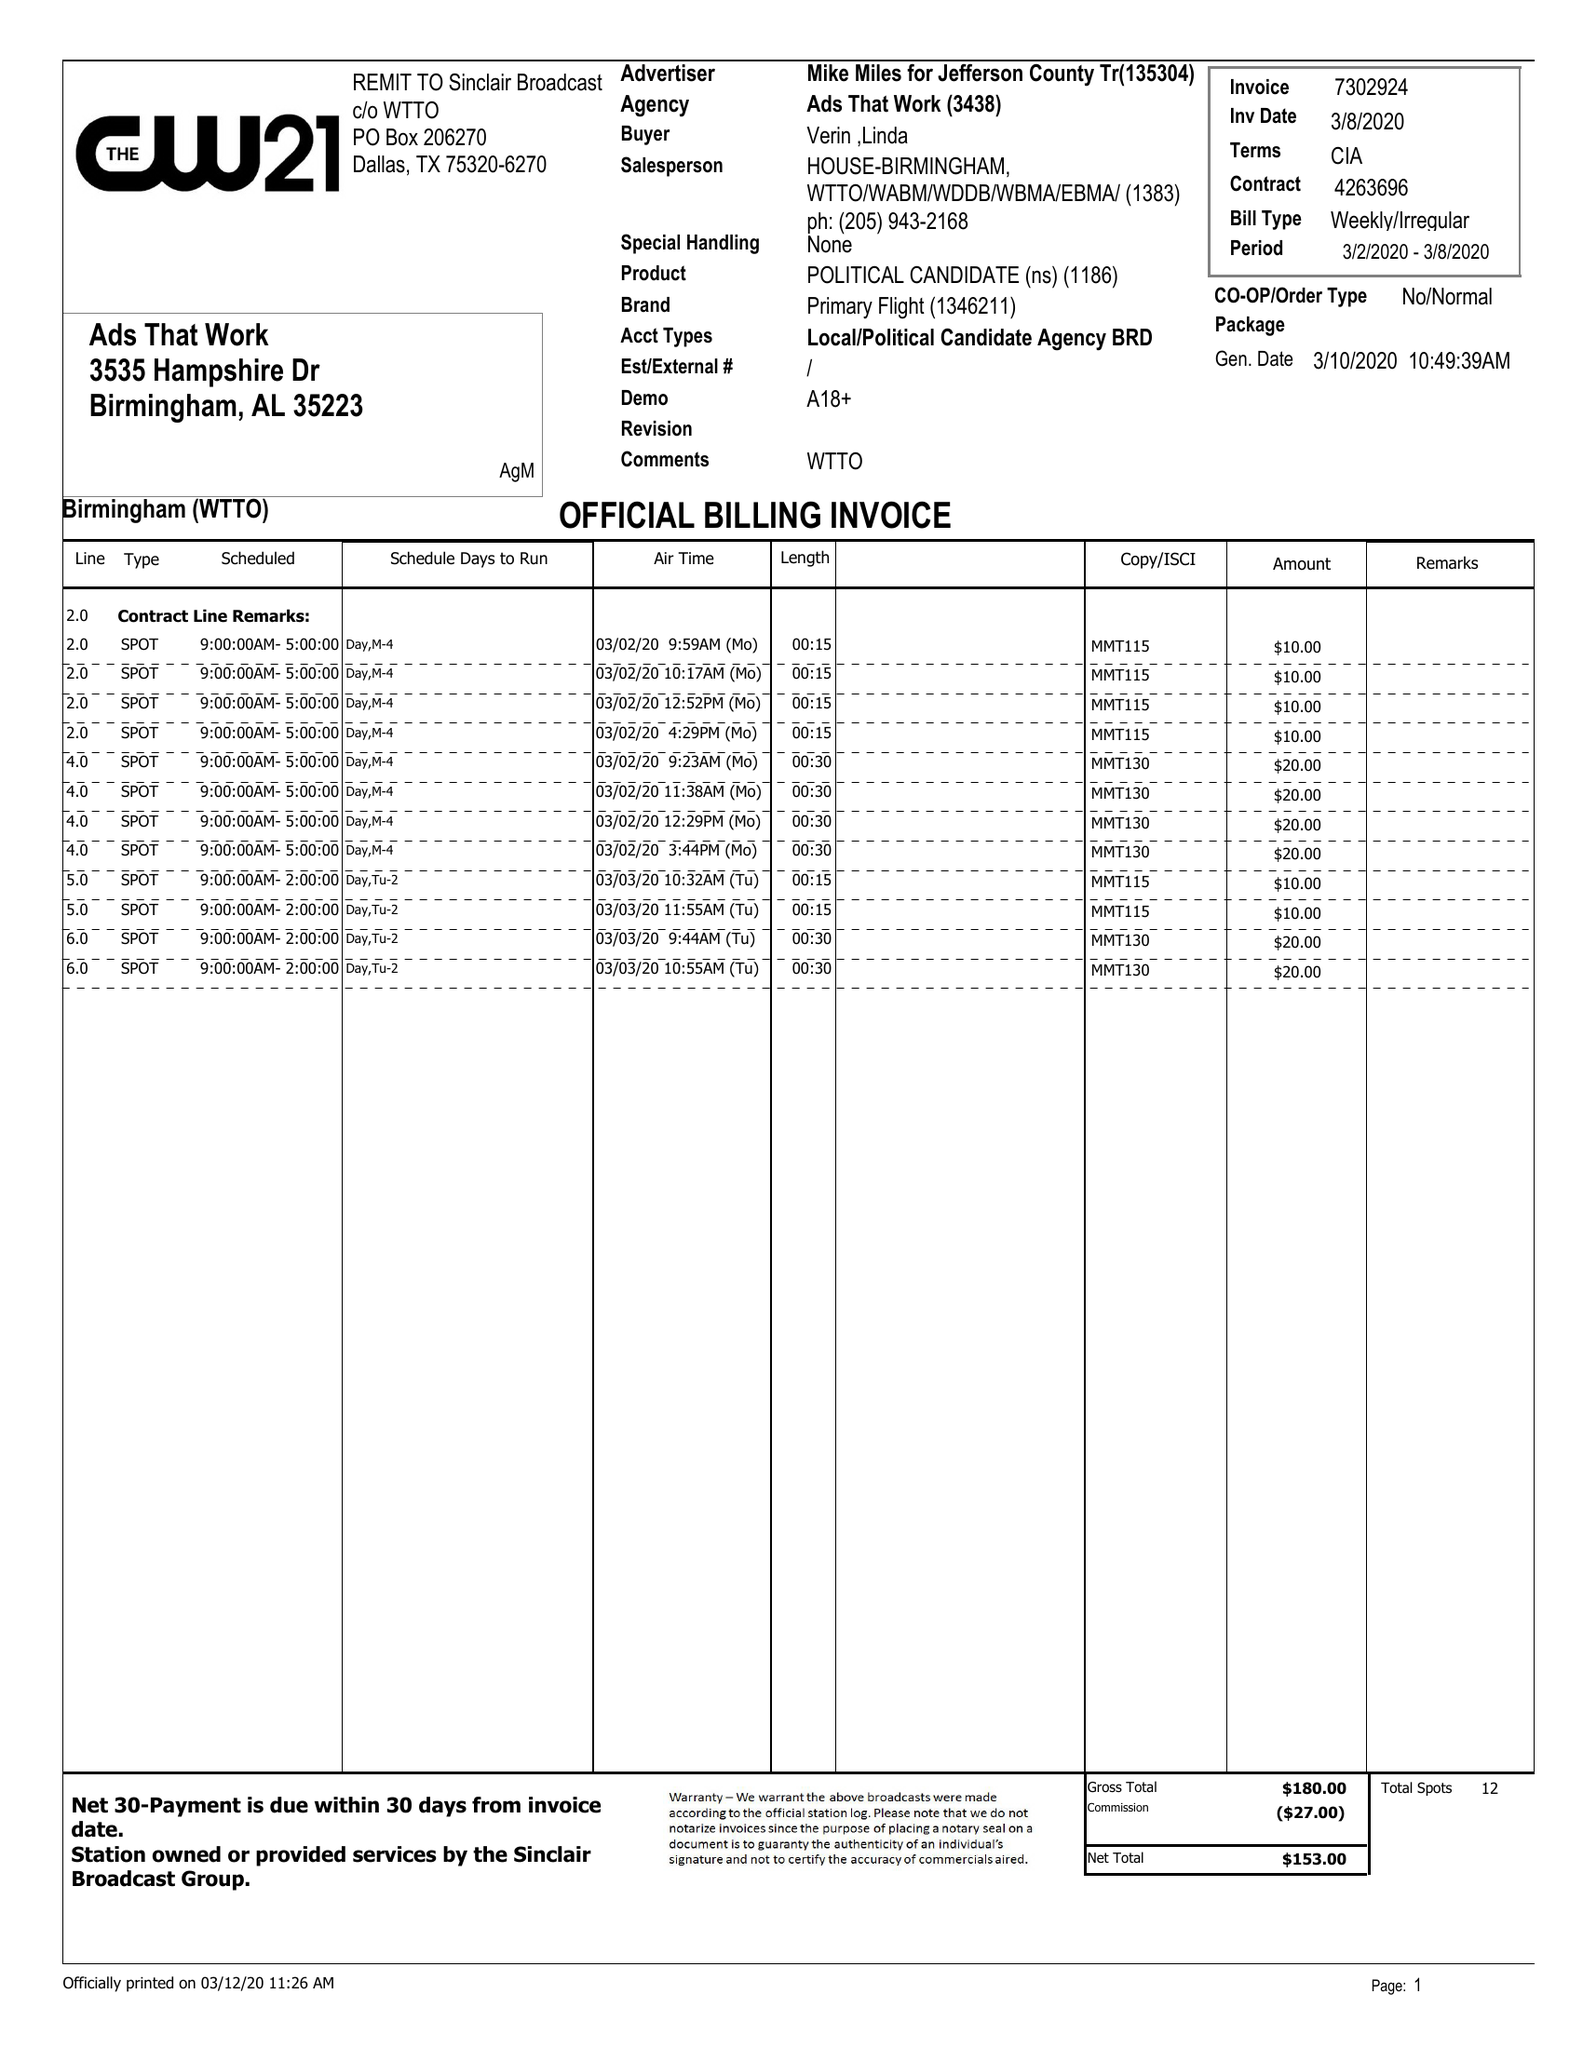What is the value for the flight_from?
Answer the question using a single word or phrase. 03/02/20 